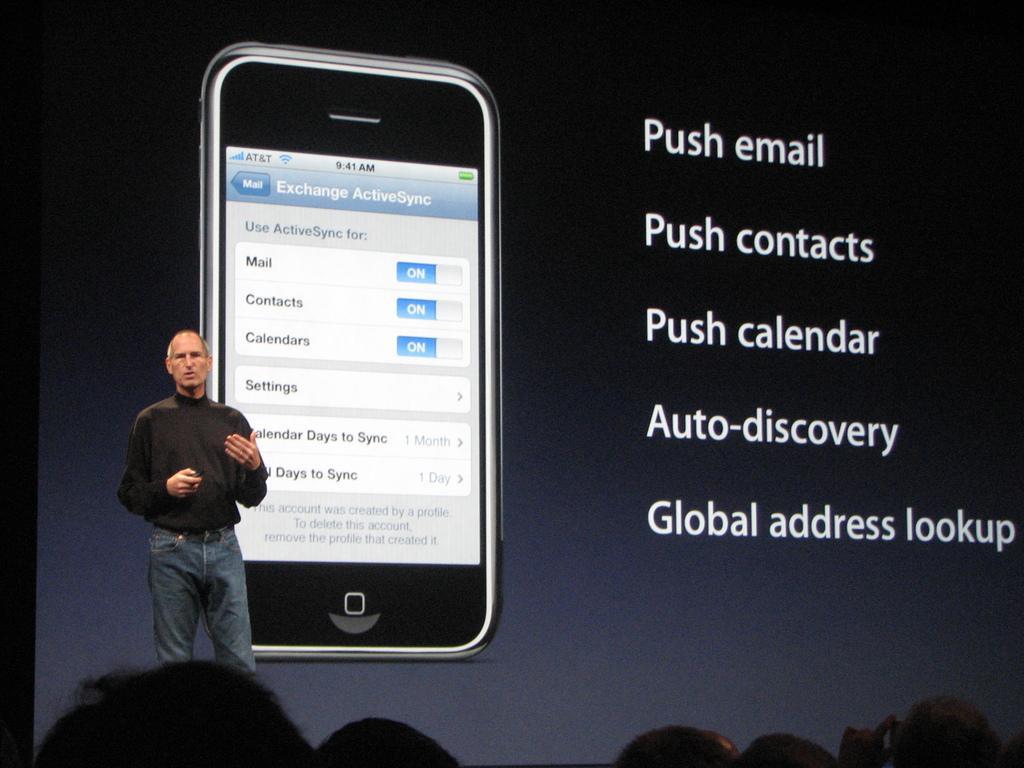What kind of phone is this?
Keep it short and to the point. Iphone. What can you lookup?
Ensure brevity in your answer.  Global address. 